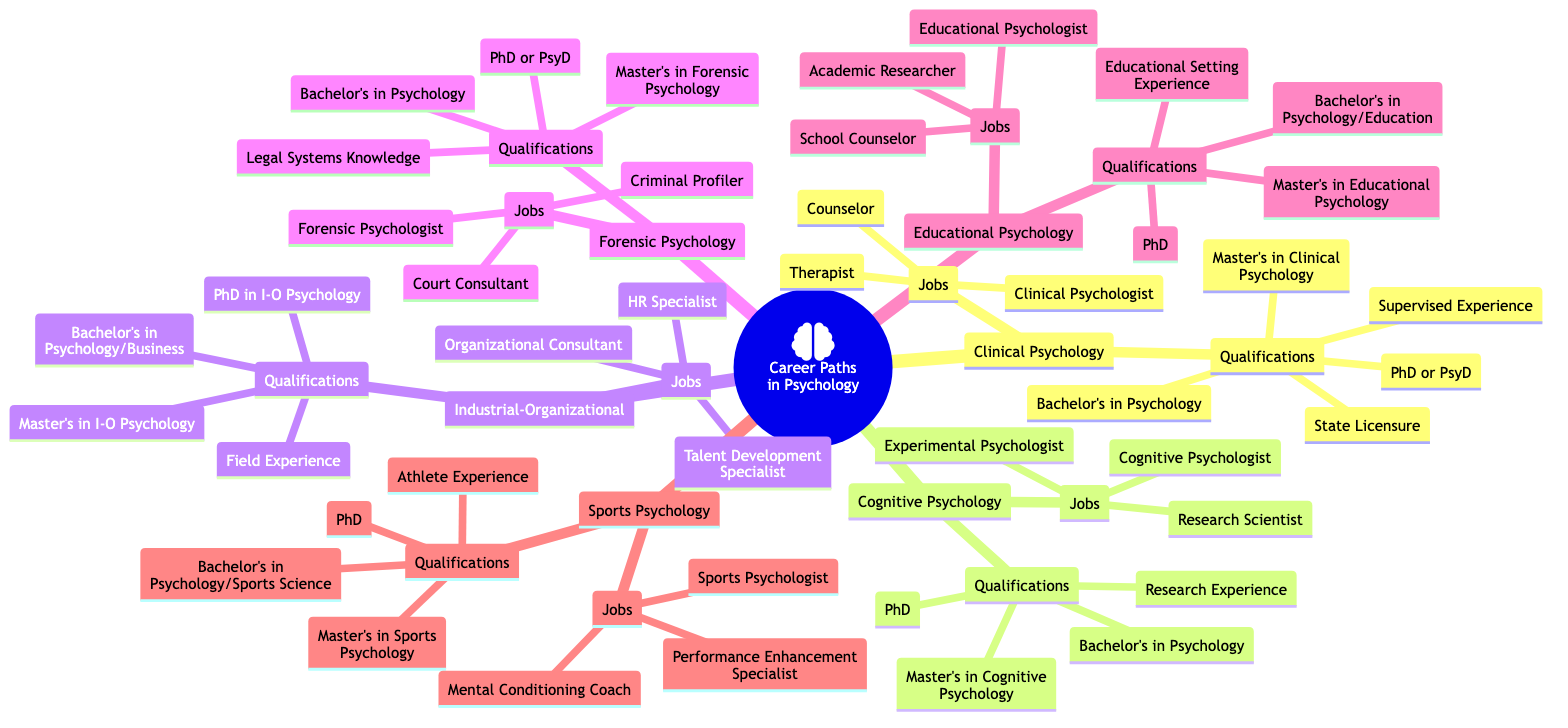What are the potential jobs in Educational Psychology? According to the diagram, the potential jobs listed under Educational Psychology include Educational Psychologist, School Counselor, and Academic Researcher. These jobs are specified within the "Jobs" section related to the Educational Psychology node.
Answer: Educational Psychologist, School Counselor, Academic Researcher How many qualifications are listed for Forensic Psychology? The diagram shows four specific qualifications listed under Forensic Psychology: Bachelor's Degree in Psychology, Master's Degree in Forensic Psychology, PhD or PsyD in Forensic Psychology, and Knowledge of Legal Systems. Counting these gives a total of four qualifications.
Answer: 4 Which career path requires experience with athletes? The Sports Psychology node specifies that one of the qualifications is "Experience with Athletes," indicating that Sports Psychology is the relevant career path that requires this specific experience.
Answer: Sports Psychology What are the educational requirements for Industrial-Organizational Psychology? The qualifications listed under Industrial-Organizational Psychology include a Bachelor's Degree in Psychology or Business, a Master's Degree in Industrial-Organizational Psychology, a PhD in Industrial-Organizational Psychology, and Field Experience. These qualifications are directly outlined in the qualifications section of that node.
Answer: Bachelor's in Psychology or Business, Master's in Industrial-Organizational Psychology, PhD in Industrial-Organizational Psychology, Field Experience Which career path has "Criminal Profiler" as a potential job? The potential job "Criminal Profiler" is found in the Forensic Psychology node under the Jobs section. This shows the specific association between the career path of Forensic Psychology and this job title.
Answer: Forensic Psychology What is the primary degree required for a Cognitive Psychologist? A Cognitive Psychologist requires a PhD in Cognitive Psychology as stated in the Qualifications section of the Cognitive Psychology node. This is the highest degree listed specifically required for clinical practice in this field.
Answer: PhD in Cognitive Psychology 